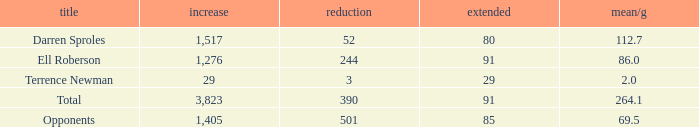When the Gain is 29, and the average per game is 2, and the player lost less than 390 yards, what's the sum of the Long yards? None. 